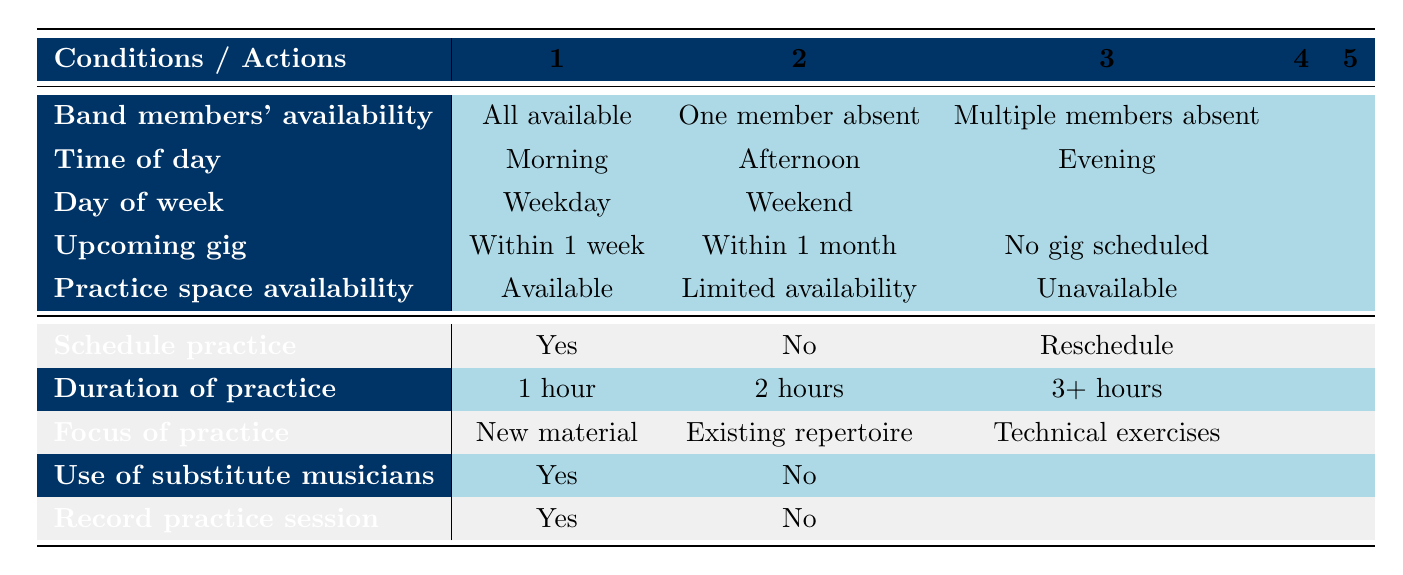What happens if all band members are available? When all band members are available, the table suggests to schedule practice. There are also options for the duration of practice, suggesting 1 hour, 2 hours, or 3+ hours.
Answer: Schedule practice is Yes If the space is unavailable, what should we do? If the practice space is unavailable, the table indicates to reschedule. There are no practice sessions scheduled, and duration cannot be applied since the space is unavailable.
Answer: Reschedule What is the focus of practice when there’s a gig within one week? With a gig scheduled within one week, the focus of practice could be on new material, existing repertoire, or technical exercises, depending on what the band decides. All focus options are available in this case.
Answer: All focus options are available How does the day of the week affect scheduling when multiple members are absent? Regardless of the day of the week, if multiple members are absent, the scheduling typically becomes a 'no' for practice unless conditions allow otherwise. This means that practice might not be scheduled on any day.
Answer: No schedule practice If we have limited practice space, how does it impact the use of substitute musicians? Limited practice space might necessitate the use of substitute musicians. If the practice cannot accommodate all members, substitutes may be required to ensure the practice can go ahead. It’s contingent on the availability of space along with members.
Answer: Yes for substitutes may be needed What would be the ideal practice duration if there is a gig in less than a month? When there’s a gig scheduled within one month, ideal durations can vary but would typically lean towards 2 hours or more to ensure adequate preparation. Longer sessions can help refine the repertoire in preparation for the gig.
Answer: Ideally 2 hours or more Should we record the practice session when the timing is in the evening and space is available? Yes, recording the practice session can be beneficial, especially in evening times when space is available as it provides a chance to review and improve.
Answer: Yes to record practice session Is it advisable to practice when one member is absent on a weekend? When one member is absent, it may not be advisable to practice on a weekend as the effectiveness could be reduced, possibly leading to a 'no' decision for scheduling practice.
Answer: Not advisable to practice 